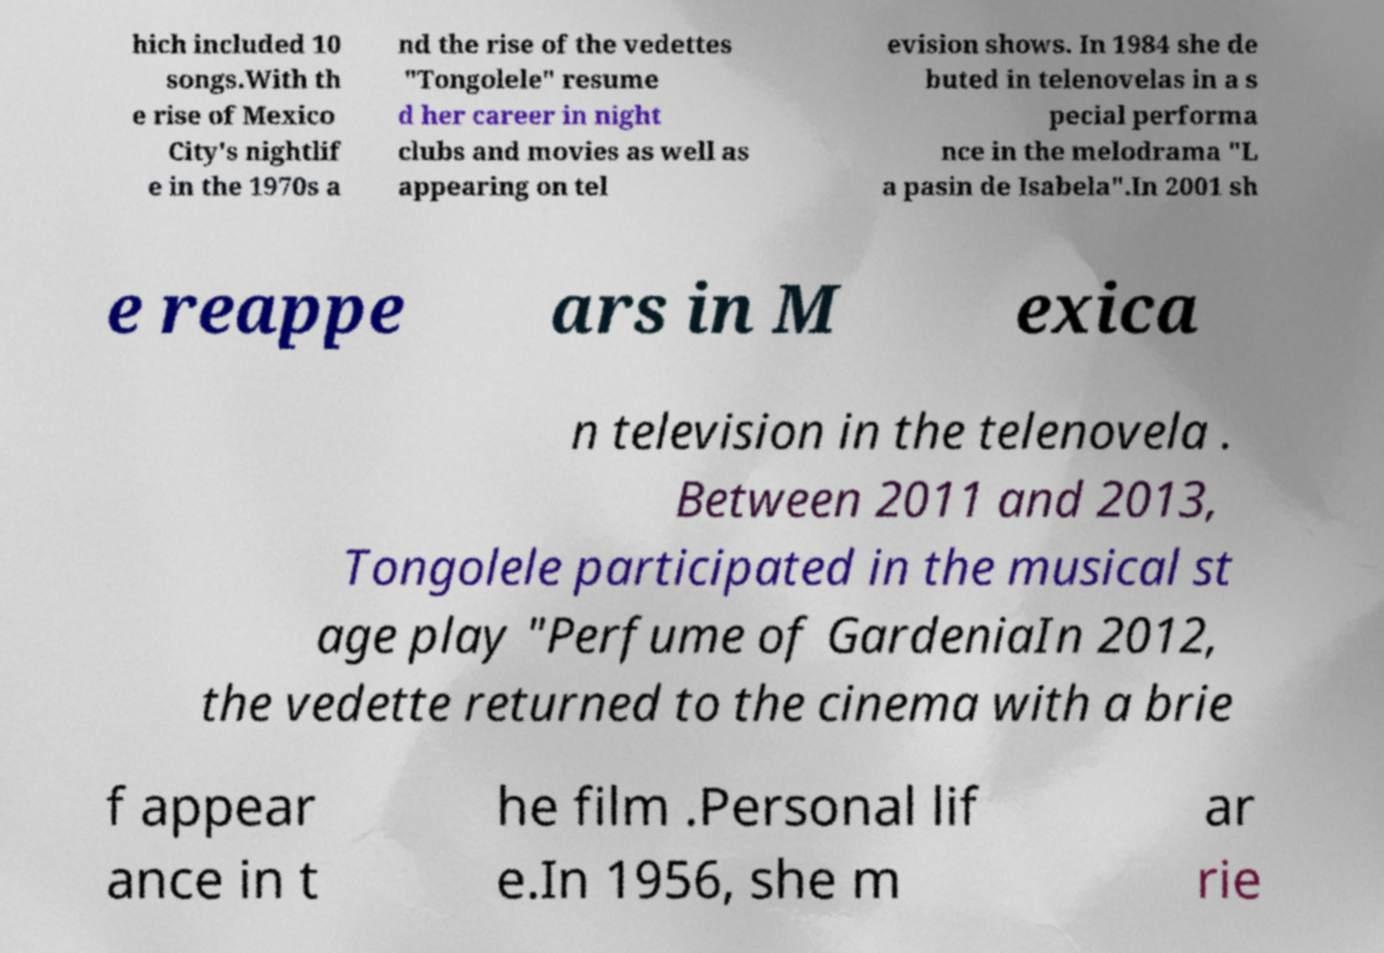Can you accurately transcribe the text from the provided image for me? hich included 10 songs.With th e rise of Mexico City's nightlif e in the 1970s a nd the rise of the vedettes "Tongolele" resume d her career in night clubs and movies as well as appearing on tel evision shows. In 1984 she de buted in telenovelas in a s pecial performa nce in the melodrama "L a pasin de Isabela".In 2001 sh e reappe ars in M exica n television in the telenovela . Between 2011 and 2013, Tongolele participated in the musical st age play "Perfume of GardeniaIn 2012, the vedette returned to the cinema with a brie f appear ance in t he film .Personal lif e.In 1956, she m ar rie 